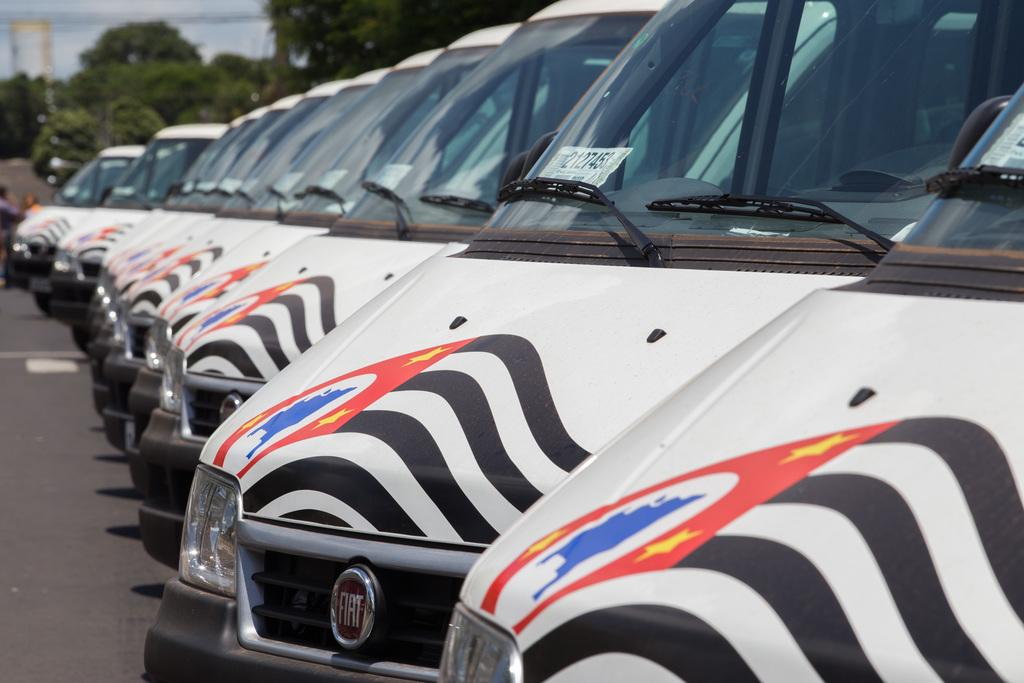What can be seen on the road in the image? There are many vehicles on the road in the image. In which direction are the vehicles facing? The vehicles are facing towards the left side. What can be seen in the background of the image? There are trees and a building in the background of the image. What type of knee is visible in the image? There is no knee present in the image; it features vehicles on a road with a background of trees and a building. 